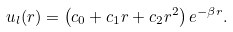<formula> <loc_0><loc_0><loc_500><loc_500>u _ { l } ( r ) = \left ( c _ { 0 } + c _ { 1 } r + c _ { 2 } r ^ { 2 } \right ) e ^ { - \beta r } .</formula> 